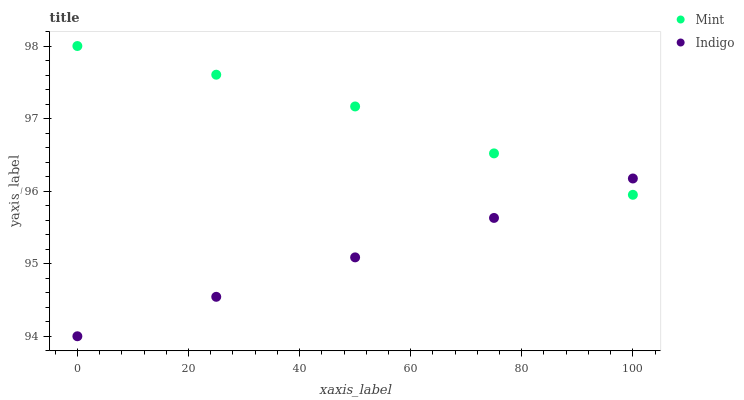Does Indigo have the minimum area under the curve?
Answer yes or no. Yes. Does Mint have the maximum area under the curve?
Answer yes or no. Yes. Does Mint have the minimum area under the curve?
Answer yes or no. No. Is Indigo the smoothest?
Answer yes or no. Yes. Is Mint the roughest?
Answer yes or no. Yes. Is Mint the smoothest?
Answer yes or no. No. Does Indigo have the lowest value?
Answer yes or no. Yes. Does Mint have the lowest value?
Answer yes or no. No. Does Mint have the highest value?
Answer yes or no. Yes. Does Indigo intersect Mint?
Answer yes or no. Yes. Is Indigo less than Mint?
Answer yes or no. No. Is Indigo greater than Mint?
Answer yes or no. No. 